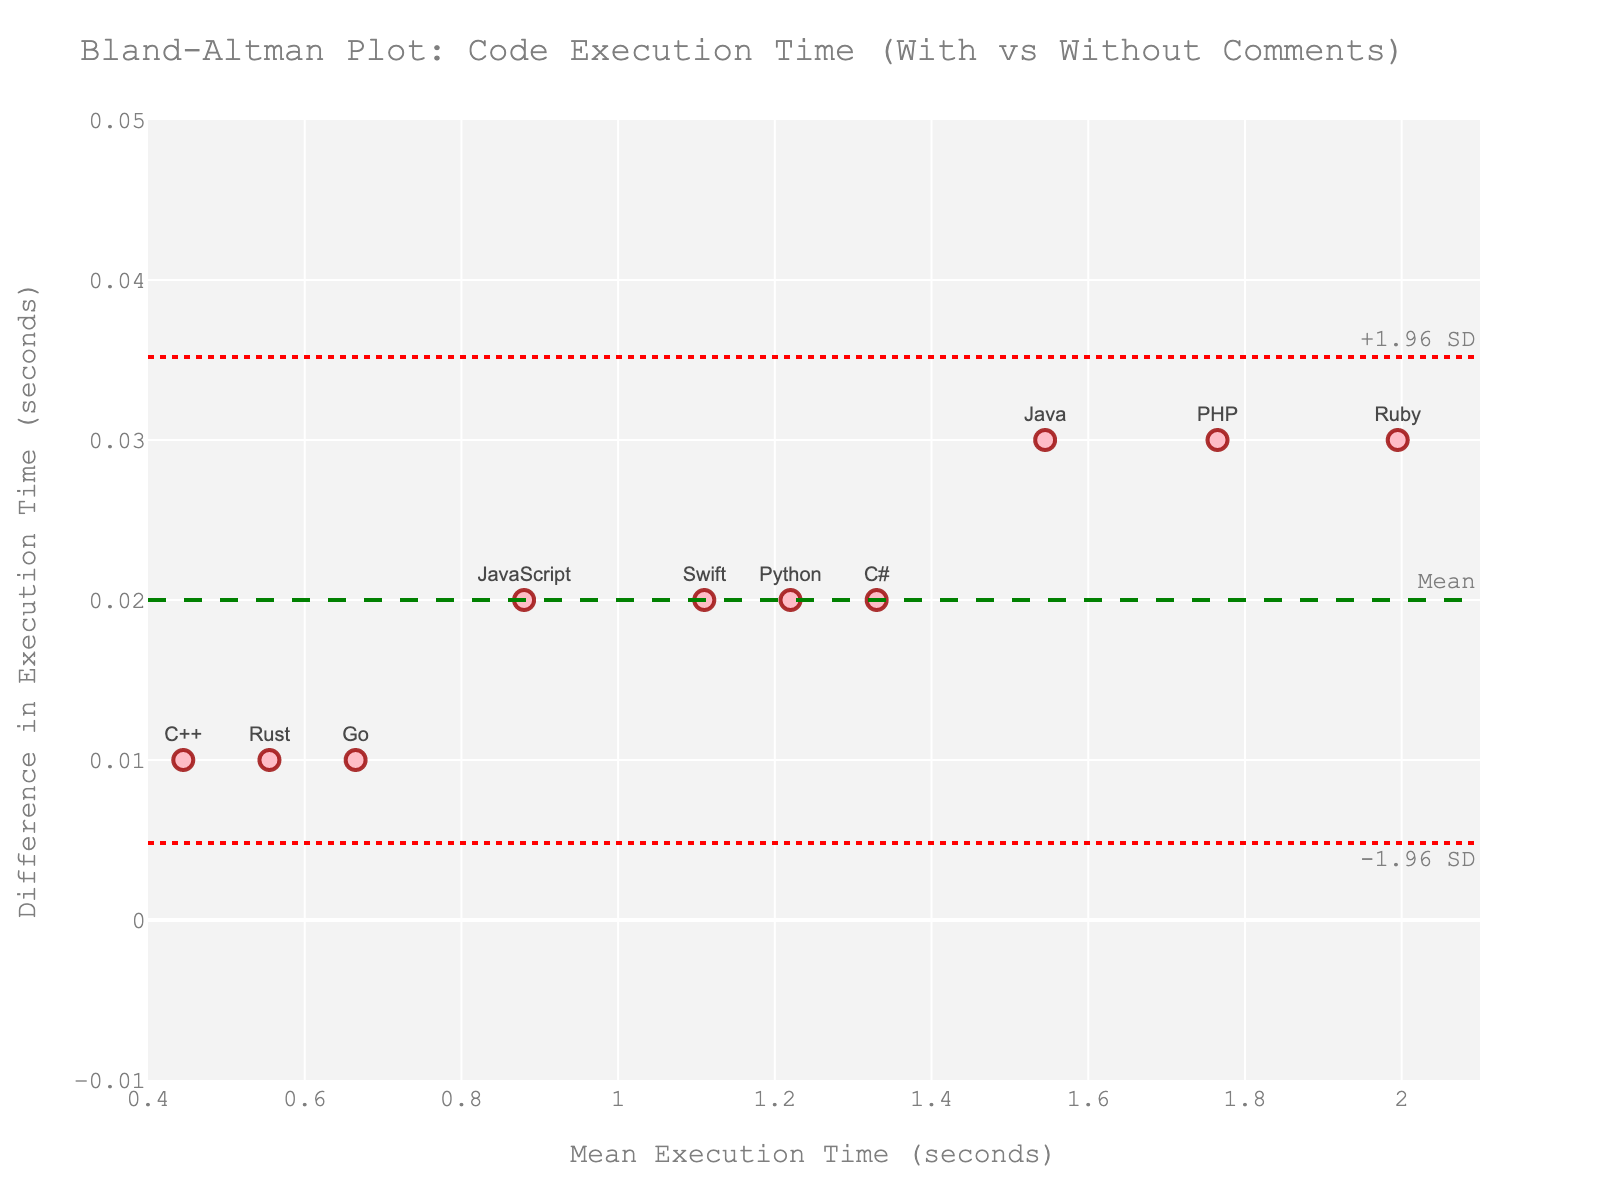what's the title of the plot? The title can be found at the top of the plot and describes what the plot is about. From the provided description, the title is "Bland-Altman Plot: Code Execution Time (With vs Without Comments)".
Answer: Bland-Altman Plot: Code Execution Time (With vs Without Comments) how many data points are there in the plot? Each programming language represents a data point in the plot. By counting the languages in the data set, we see that there are 10.
Answer: 10 what's the mean difference in execution time? The mean difference is drawn as a horizontal green dashed line on the plot. By referring to the code, we know it's the average of the differences listed in the data.
Answer: 0.02 which programming language shows the highest difference in execution time? To find the programming language with the highest difference in execution time, look for the highest point along the y-axis that labels the difference and check the corresponding language label. According to the data, Java, Ruby, and PHP have the highest difference of 0.03.
Answer: Java, Ruby, PHP what's the mean execution time for Python? The mean execution time for each language is listed in the "mean" column of the data. For Python, it is 1.22.
Answer: 1.22 which programming languages have identical differences in execution time? By comparing the differences in the data, we see that Python, JavaScript, C#, and Swift all have a difference of 0.02.
Answer: Python, JavaScript, C#, Swift which language has the smallest difference in execution time? To find the smallest difference, look for the lowest point along the y-axis that labels the difference and identify the corresponding language. According to the data, C++, Go, and Rust have the smallest difference of 0.01.
Answer: C++, Go, Rust what is the range of the x-axis? The range of the x-axis can be seen by looking at the limits set on the plot. According to the provided code, the range is between 0.4 and 2.1 seconds.
Answer: 0.4 to 2.1 seconds how many programming languages are within the ±1.96 standard deviations of the mean difference in execution time? The ±1.96 standard deviations lines are drawn as dotted red lines on the plot. All programming languages lie within these bounds as we look at the position of the points relative to these lines.
Answer: 10 what does the solid green line represent in the plot? The solid green line is labeled "Mean" and represents the average difference in execution time across all programming languages, which is calculated by averaging the differences listed in the dataset.
Answer: Mean difference in execution time 